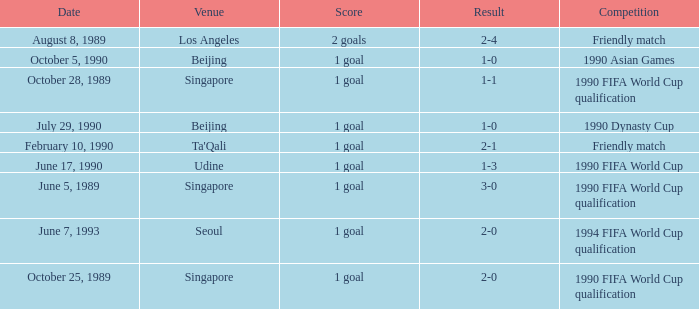What was the score of the match with a 3-0 result? 1 goal. Write the full table. {'header': ['Date', 'Venue', 'Score', 'Result', 'Competition'], 'rows': [['August 8, 1989', 'Los Angeles', '2 goals', '2-4', 'Friendly match'], ['October 5, 1990', 'Beijing', '1 goal', '1-0', '1990 Asian Games'], ['October 28, 1989', 'Singapore', '1 goal', '1-1', '1990 FIFA World Cup qualification'], ['July 29, 1990', 'Beijing', '1 goal', '1-0', '1990 Dynasty Cup'], ['February 10, 1990', "Ta'Qali", '1 goal', '2-1', 'Friendly match'], ['June 17, 1990', 'Udine', '1 goal', '1-3', '1990 FIFA World Cup'], ['June 5, 1989', 'Singapore', '1 goal', '3-0', '1990 FIFA World Cup qualification'], ['June 7, 1993', 'Seoul', '1 goal', '2-0', '1994 FIFA World Cup qualification'], ['October 25, 1989', 'Singapore', '1 goal', '2-0', '1990 FIFA World Cup qualification']]} 